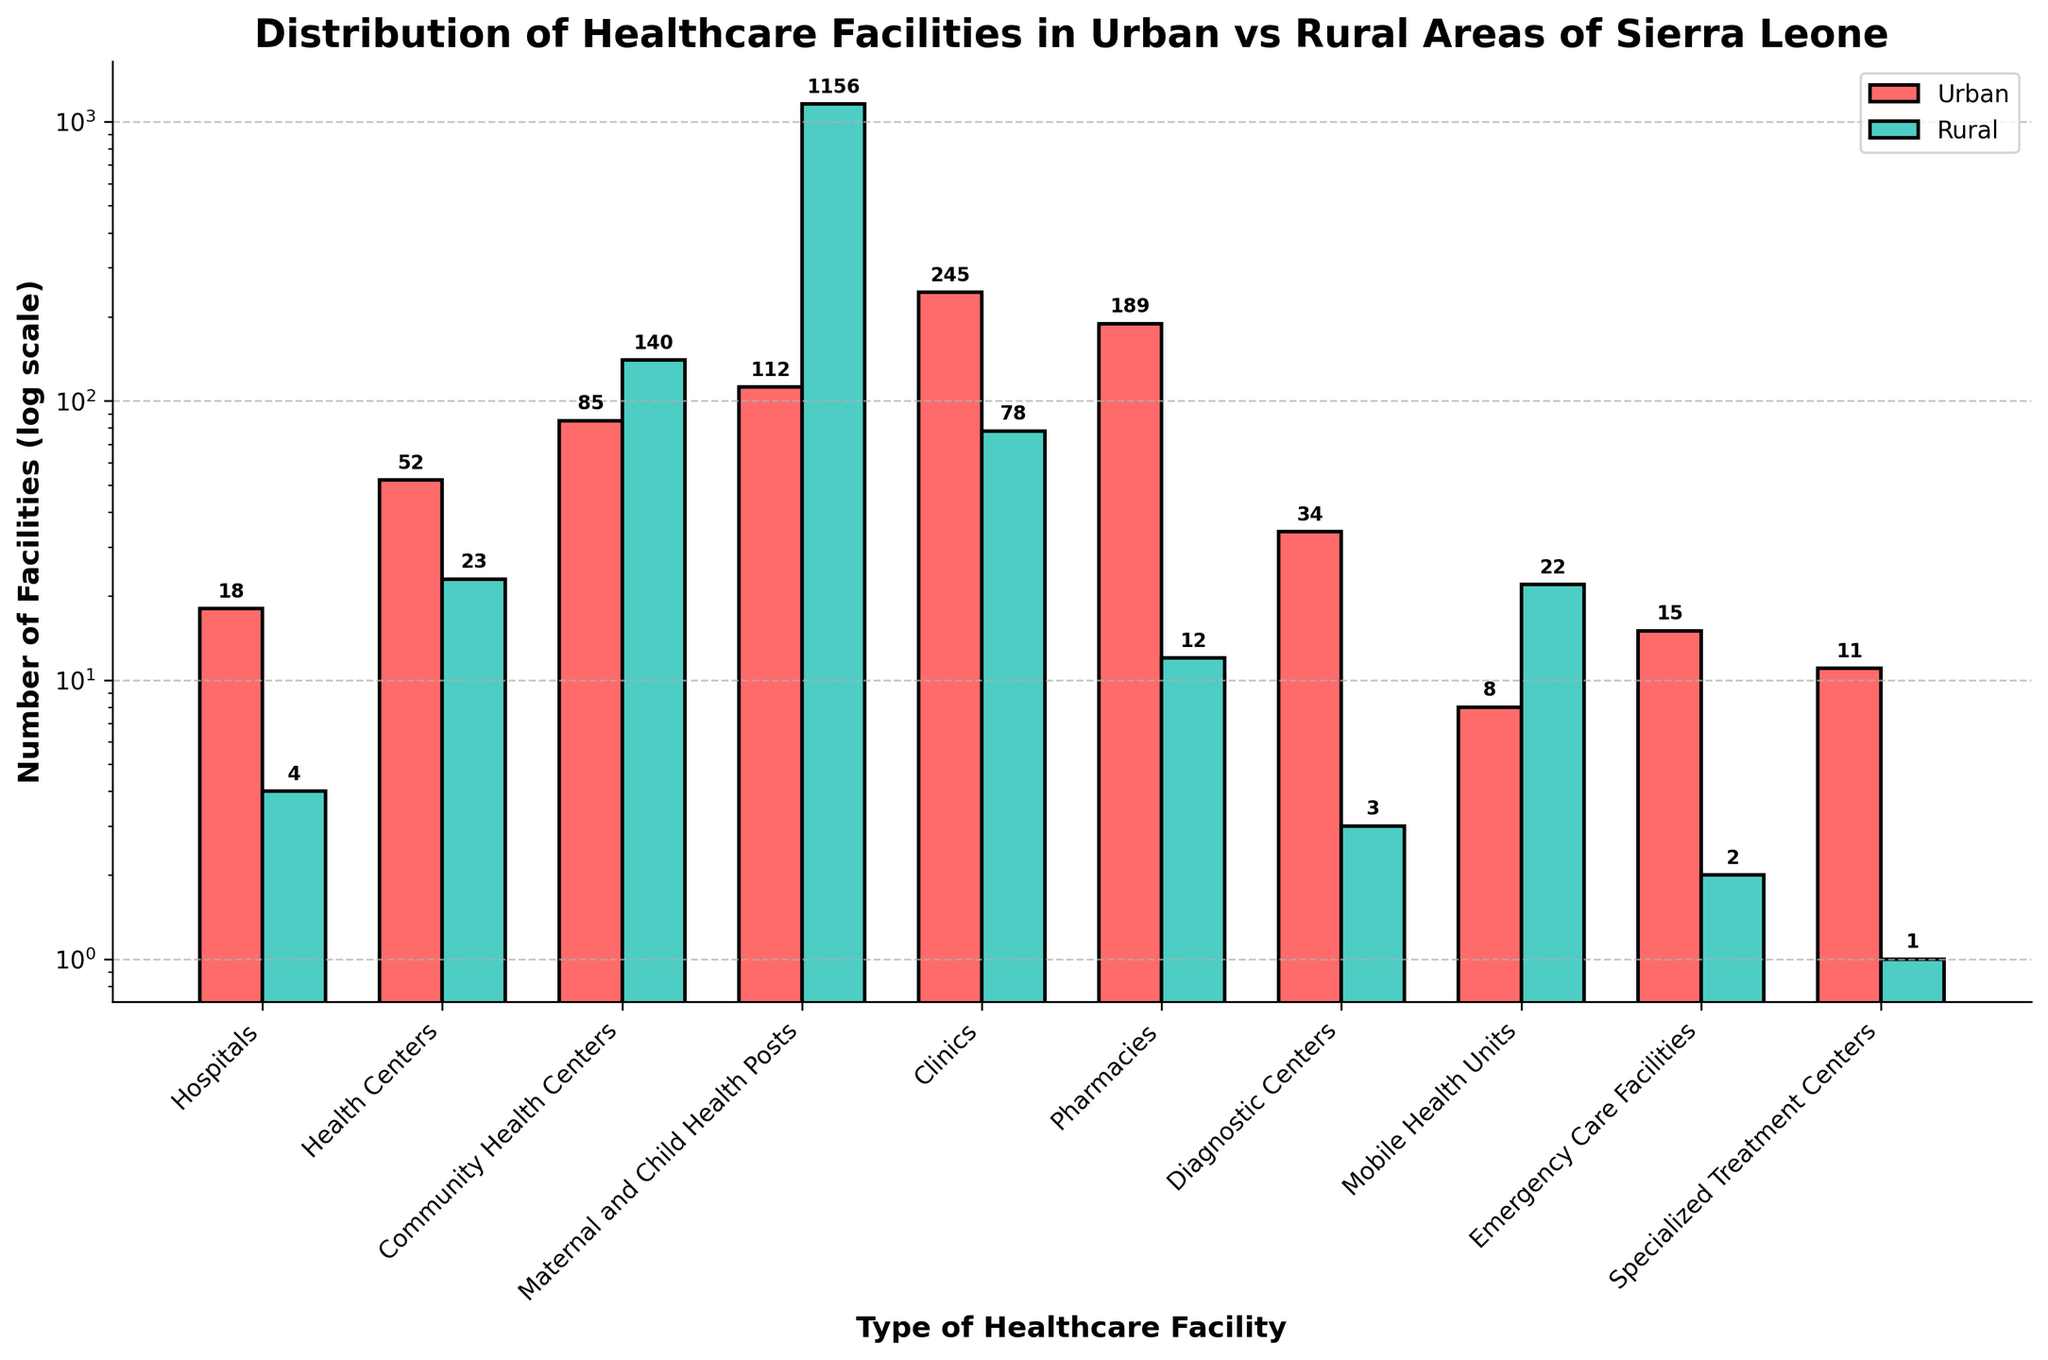What's the total number of Hospitals in both Urban and Rural areas? To find the total number of hospitals, sum the numbers in both Urban (18) and Rural (4) areas. So, 18 + 4 = 22
Answer: 22 Which type of healthcare facility has the highest number in Rural areas? Observe the heights of the bars for Rural areas. The tallest bar is for Maternal and Child Health Posts with 1156 facilities.
Answer: Maternal and Child Health Posts How do the numbers of Clinics compare between Urban and Rural areas? Compare the heights of the bars for Clinics in Urban (245) and Rural (78) areas. 245 is greater than 78.
Answer: Urban has more Clinics than Rural What's the difference between the number of Urban and Rural Pharmacies? Subtract the Rural number (12) from the Urban number (189). So, 189 - 12 = 177
Answer: 177 Which type of facility has no more than 10 in both Urban and Rural areas? Observe the heights of both bars for each facility type and identify those under 10. Specialized Treatment Centers (Urban: 11, Rural: 1) almost fits but doesn't. Mobile Health Units (Urban: 8, Rural: 22), however, partly fits with Urban. Emergency Care Facilities (Urban: 15, Rural: 2) also fits with Rural.
Answer: Mobile Health Units (Urban), Emergency Care Facilities (Rural) How many more Community Health Centers are in Rural areas compared to Urban areas? Subtract the Urban number (85) from the Rural number (140). So, 140 - 85 = 55
Answer: 55 What's the sum of Diagnostic Centers and Emergency Care Facilities in Urban areas? Add the numbers of Diagnostic Centers (34) and Emergency Care Facilities (15) in Urban areas. So, 34 + 15 = 49
Answer: 49 Which area, Urban or Rural, has more total healthcare facilities? (Consider all types) Add up all the Urban numbers and all the Rural numbers separately, then compare the totals. Urban: 18+52+85+112+245+189+34+8+15+11 = 769, Rural: 4+23+140+1156+78+12+3+22+2+1 = 1441. Rural has more.
Answer: Rural Which type of healthcare facility has the lowest number in Urban areas? Observe the shortest bar in the Urban area, which is Mobile Health Units with 8 facilities.
Answer: Mobile Health Units 